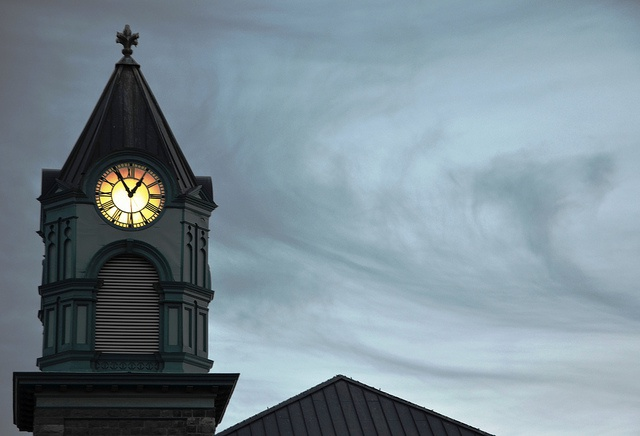Describe the objects in this image and their specific colors. I can see a clock in gray, black, ivory, khaki, and tan tones in this image. 